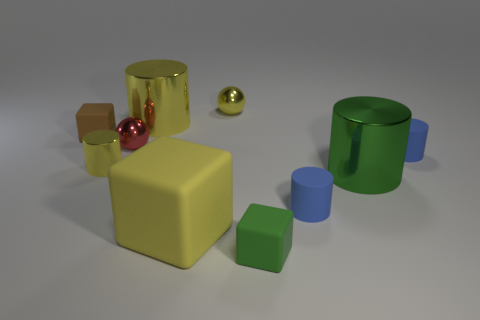Subtract all yellow cubes. How many cubes are left? 2 Subtract all blue cylinders. How many cylinders are left? 3 Subtract all balls. How many objects are left? 8 Subtract 1 cylinders. How many cylinders are left? 4 Subtract all purple cubes. Subtract all red cylinders. How many cubes are left? 3 Subtract all yellow cylinders. How many cyan blocks are left? 0 Subtract all big metal objects. Subtract all blue matte cylinders. How many objects are left? 6 Add 8 yellow rubber objects. How many yellow rubber objects are left? 9 Add 6 tiny red things. How many tiny red things exist? 7 Subtract 0 red cylinders. How many objects are left? 10 